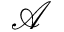<formula> <loc_0><loc_0><loc_500><loc_500>\mathcal { A }</formula> 